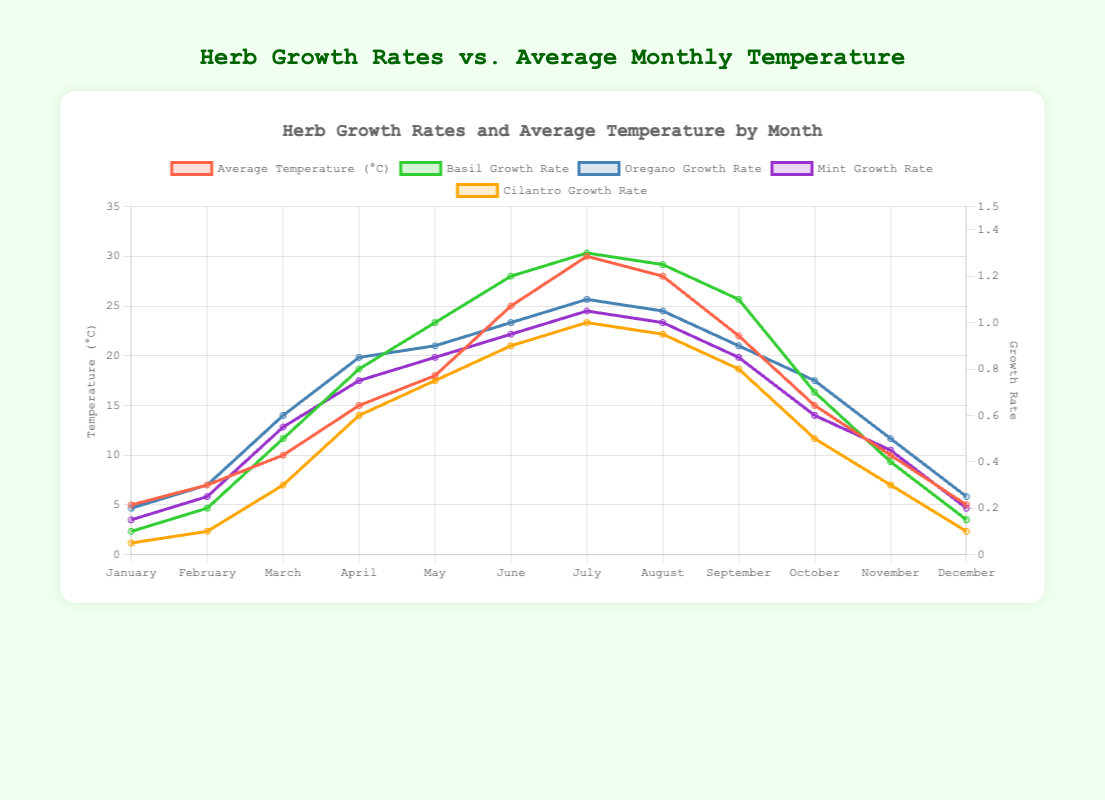How does the growth rate of basil compare to oregano in the month of July? In July, the growth rate of basil is 1.3, and the growth rate of oregano is 1.1. Since 1.3 is greater than 1.1, the growth rate of basil is higher.
Answer: Basil grows faster than oregano in July Which herb shows the least growth rate in February? In February, the growth rates are as follows: basil (0.2), oregano (0.3), mint (0.25), and cilantro (0.1). Cilantro has the lowest growth rate.
Answer: Cilantro During which month does basil have its highest growth rate? By observing the growth rates of basil over the months, the highest value is 1.3, which occurs in July.
Answer: July What is the average growth rate of mint between March and June? The growth rates for mint from March to June are 0.55, 0.75, 0.85, and 0.95. The sum is 0.55 + 0.75 + 0.85 + 0.95 = 3.1. Dividing by 4, the average is 3.1 / 4 = 0.775.
Answer: 0.775 If the temperature drops from July to December, how do the growth rates of oregano and mint change in December compared to July? In July, oregano's growth rate is 1.1 and mint's is 1.05. In December, oregano's growth rate is 0.25 and mint's is 0.2. Both herbs experience a drop in their growth rates: oregano (1.1 to 0.25) and mint (1.05 to 0.2).
Answer: Both oregano and mint's growth rates decrease What is the temperature range observed across the months? The lowest temperature is 5°C (January and December), and the highest is 30°C (July). The range is 30 - 5 = 25°C.
Answer: 25°C Which month shows the highest growth rate for cilantro, and what is that rate? By looking through the cilantro's growth rates for each month, the highest rate is 1.0, which occurs in July.
Answer: July, 1.0 Compare the growth rates of all herbs in March. Which herb shows the highest growth rate, and what is that rate? In March, the growth rates for each herb are: basil (0.5), oregano (0.6), mint (0.55), and cilantro (0.3). Oregano has the highest growth rate of 0.6.
Answer: Oregano, 0.6 What is the overall trend in the growth rate of basil from January to July? The basil growth rate increases continually from January (0.1) to July (1.3).
Answer: Increasing trend 